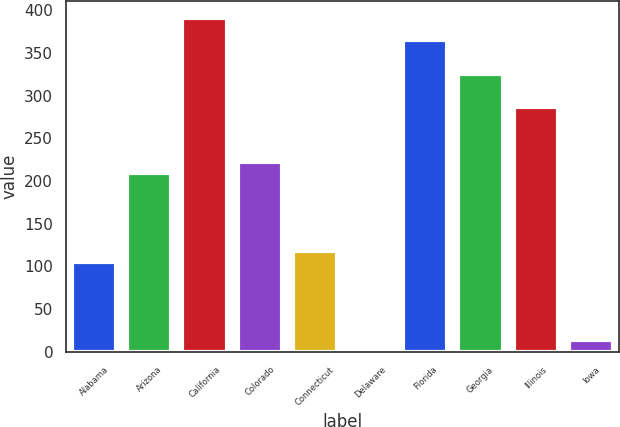Convert chart. <chart><loc_0><loc_0><loc_500><loc_500><bar_chart><fcel>Alabama<fcel>Arizona<fcel>California<fcel>Colorado<fcel>Connecticut<fcel>Delaware<fcel>Florida<fcel>Georgia<fcel>Illinois<fcel>Iowa<nl><fcel>105<fcel>209<fcel>391<fcel>222<fcel>118<fcel>1<fcel>365<fcel>326<fcel>287<fcel>14<nl></chart> 